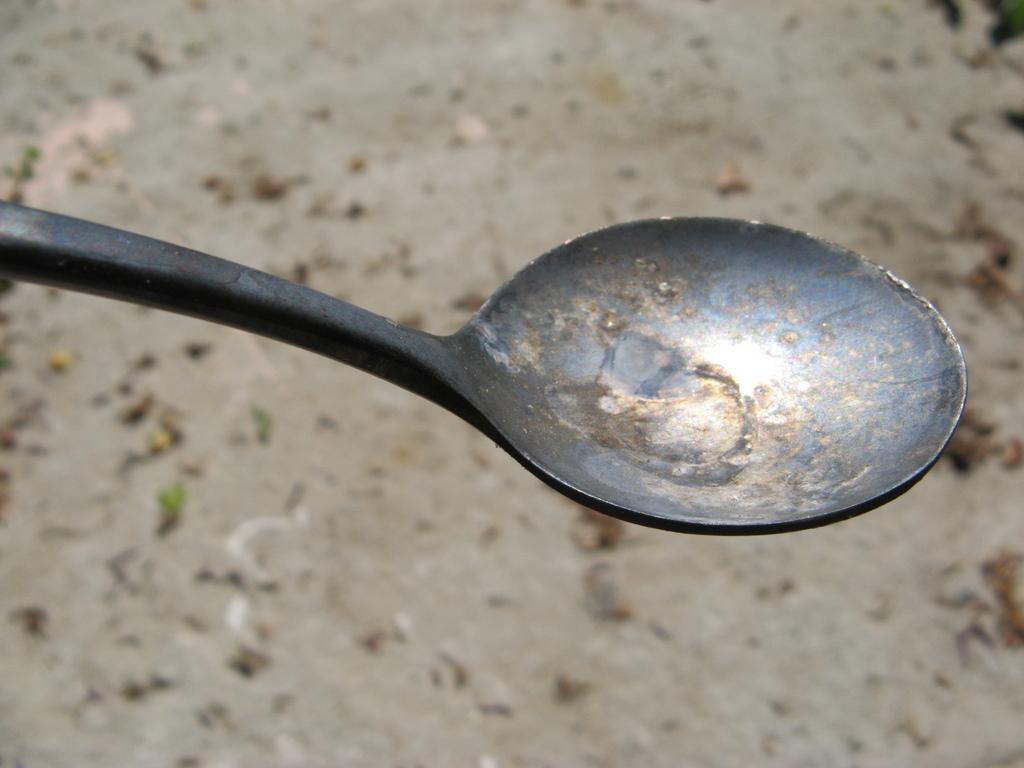Describe this image in one or two sentences. In the picture we can see a spoon. 